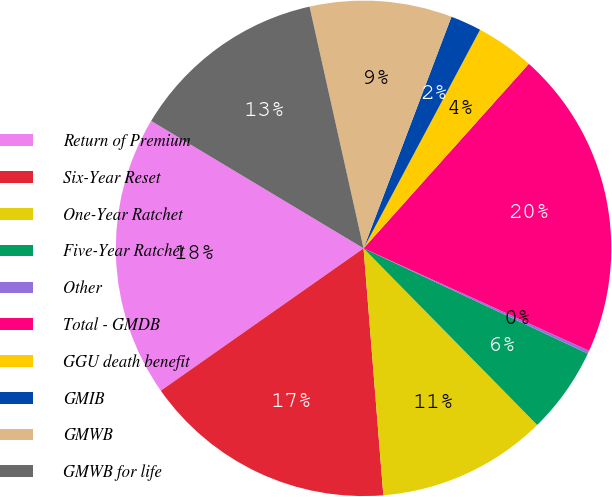Convert chart. <chart><loc_0><loc_0><loc_500><loc_500><pie_chart><fcel>Return of Premium<fcel>Six-Year Reset<fcel>One-Year Ratchet<fcel>Five-Year Ratchet<fcel>Other<fcel>Total - GMDB<fcel>GGU death benefit<fcel>GMIB<fcel>GMWB<fcel>GMWB for life<nl><fcel>18.34%<fcel>16.53%<fcel>11.09%<fcel>5.65%<fcel>0.2%<fcel>20.16%<fcel>3.83%<fcel>2.02%<fcel>9.27%<fcel>12.9%<nl></chart> 